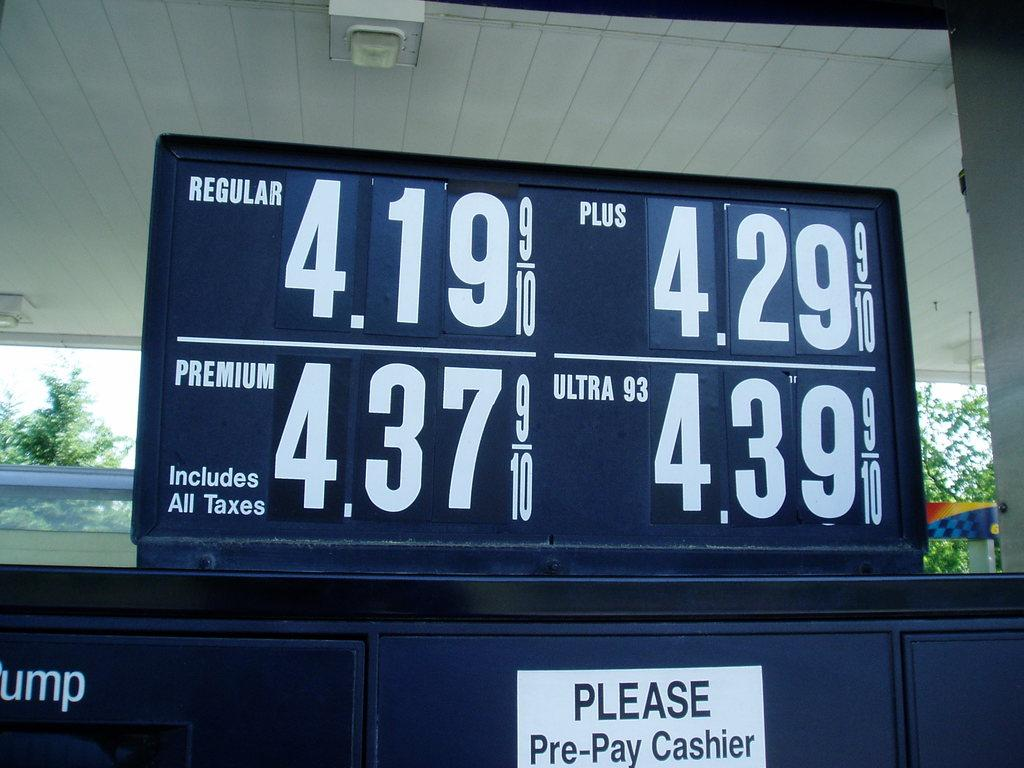<image>
Offer a succinct explanation of the picture presented. gas prices above a gas pump that are 4.19 